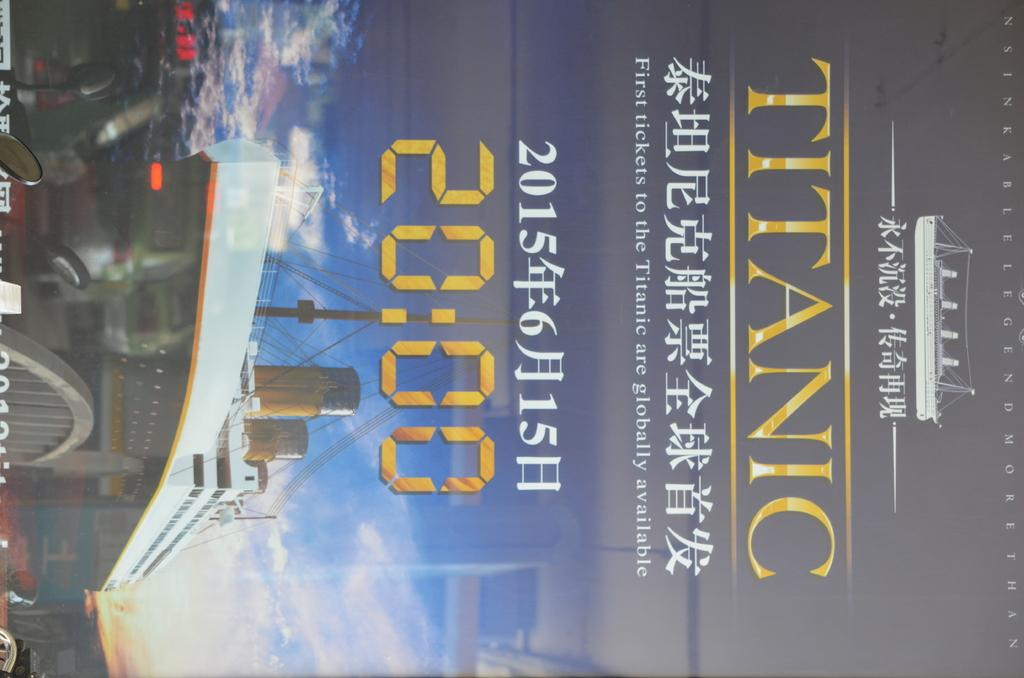<image>
Render a clear and concise summary of the photo. The movie title is labeled "Titanic" in gold colors. 